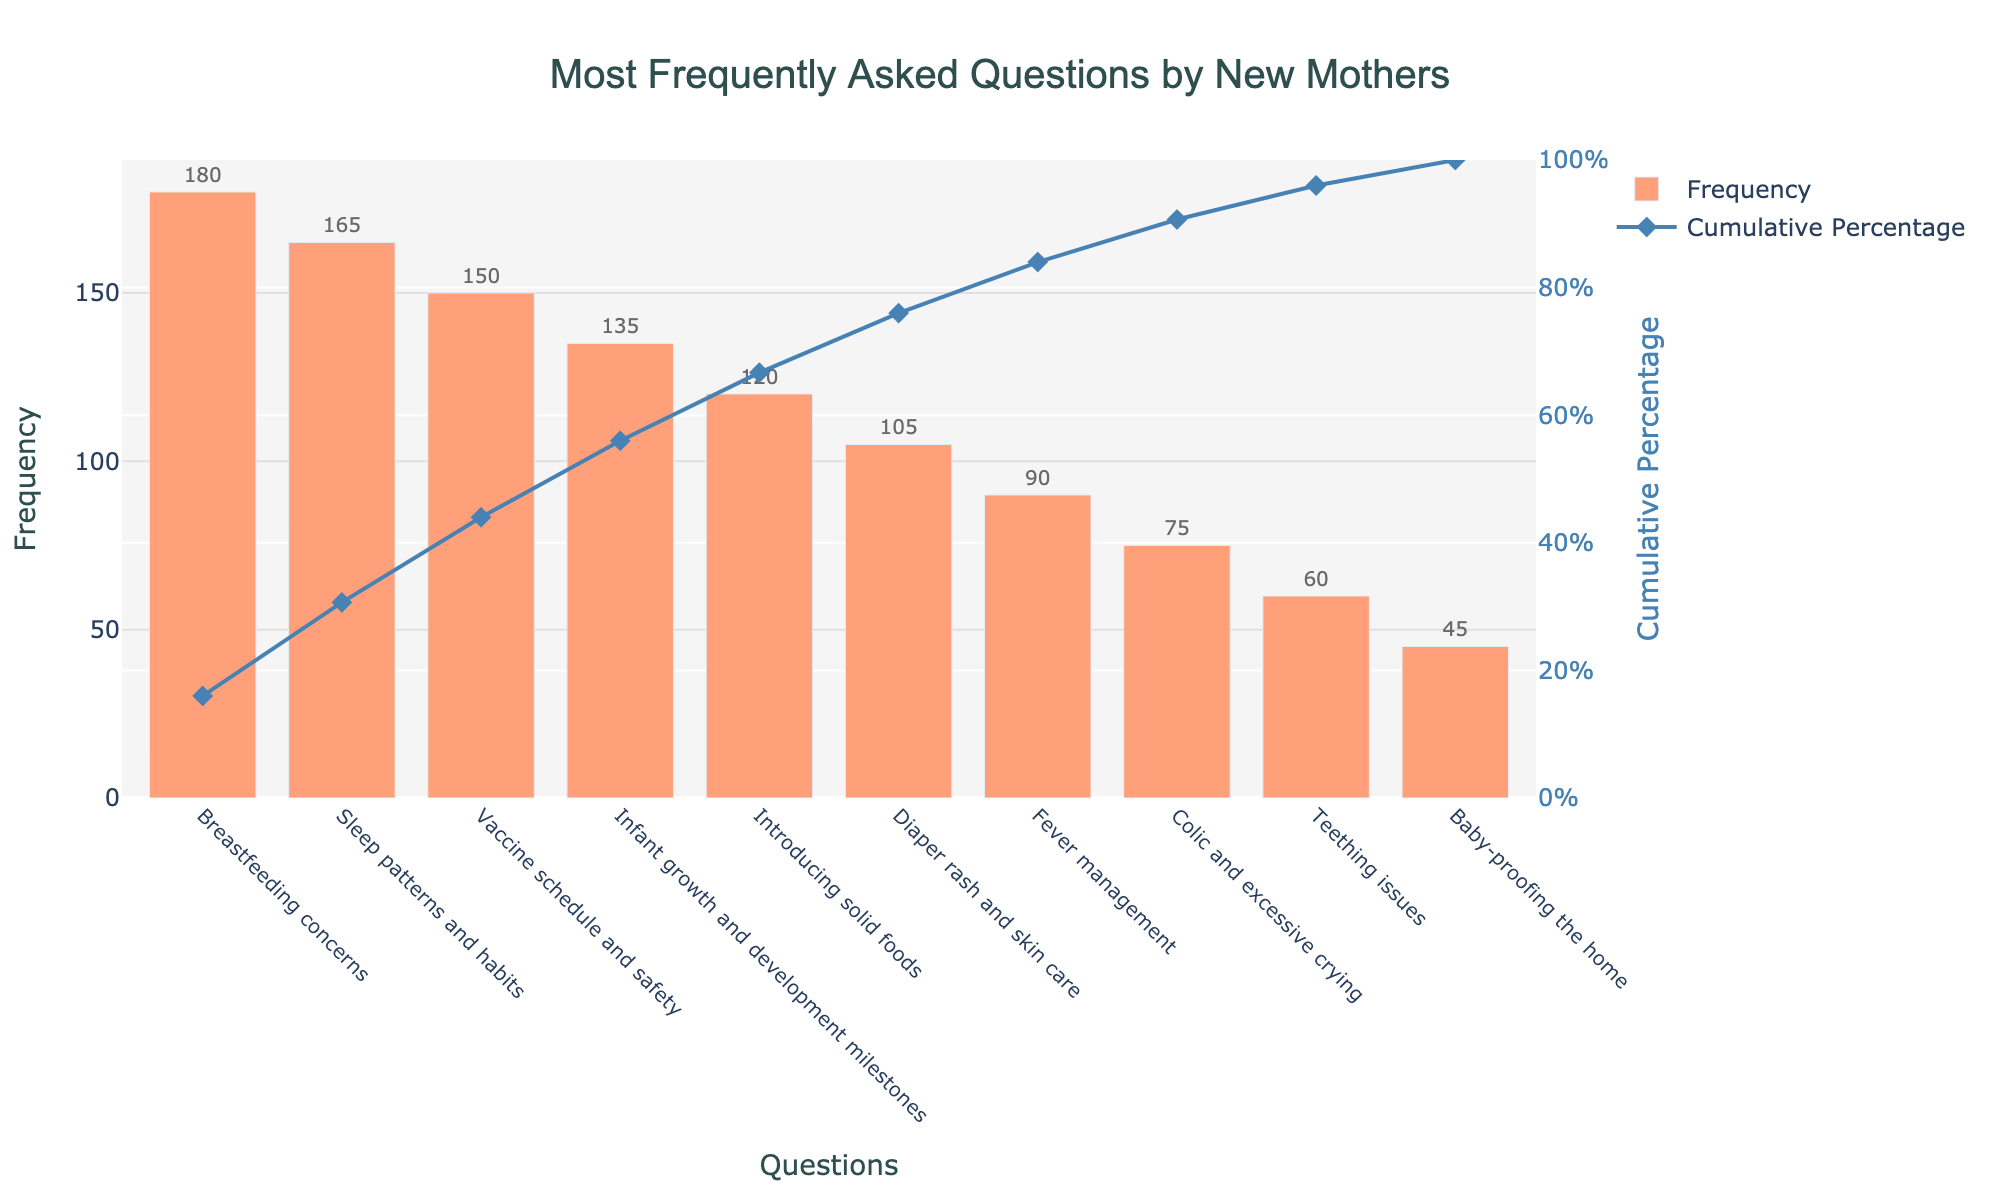What is the title of the chart? The title is usually located at the top of the chart and gives a summary of what the chart represents. In this case, it reads "Most Frequently Asked Questions by New Mothers".
Answer: Most Frequently Asked Questions by New Mothers Which question had the highest frequency? Look at the bars and find the tallest one, then read the corresponding label on the x-axis. According to the chart, 'Breastfeeding concerns' is the highest.
Answer: Breastfeeding concerns What are the top three most frequently asked questions? Identify the top three tallest bars and their corresponding labels on the x-axis. The highest frequencies are: 'Breastfeeding concerns', 'Sleep patterns and habits', and 'Vaccine schedule and safety'.
Answer: Breastfeeding concerns, Sleep patterns and habits, Vaccine schedule and safety What is the cumulative percentage after the top three questions? The cumulative percentage line indicates the sum of the frequencies up to each question. After 'Vaccine schedule and safety', the cumulative percentage is about 56.3%.
Answer: 56.3% How many questions have a frequency of 120 or more? Identify the bars that have labels above 120 and count them. The questions are: 'Breastfeeding concerns', 'Sleep patterns and habits', 'Vaccine schedule and safety', and 'Infant growth and development milestones'.
Answer: 4 Which question has the lowest frequency? Identify the shortest bar and read the corresponding label on the x-axis. 'Baby-proofing the home' has the lowest frequency of 45.
Answer: Baby-proofing the home What is the cumulative percentage contributed by 'Diaper rash and skin care' and 'Fever management'? Find the cumulative percentage points for both questions and subtract the percentage of 'Fever management' from that of 'Diaper rash and skin care'. The cumulative percentage after 'Diaper rash and skin care' is about 78.6% and after 'Fever management' is about 89%, so 89% - 78.6% gives 10.4%.
Answer: 10.4% Which two questions have exactly 15-frequency points difference? Compare the differences in the heights of the bars visually or by referring to their numerical values. 'Infant growth and development milestones' (135) and 'Introducing solid foods' (120) have exactly a 15-point difference.
Answer: Infant growth and development milestones and Introducing solid foods What percentage of the questions contribute to 50% of the total frequency? Find the cumulative percentage line, track where it hits 50%, and count the number of questions up to that point. By tracing the cumulative percentage line, 'Vaccine schedule and safety' hits around 56.3%, and 'Infant growth and development milestones' above that, so 50% is within the first three questions, which is roughly 30% of the questions (3 out of 10).
Answer: 30% If the cumulative percentage at 'Colic and excessive crying' is disregarded, what is the new cumulative percentage after 'Teething issues'? First, determine the cumulative percentage just before 'Colic and excessive crying' and add the frequency of 'Teething issues' to compute the new percentage. Ignoring 'Colic and excessive crying' (5 out of 10 cumulative frequency points), the new total cumulative from 6th to 10th questions, including 'Teething issues' at 8th and ignoring 9th, will shift the cumulative percentage slightly but largely remain within approximate values.
Answer: Approximately 85% after excluding 'Colic and excessive crying' 